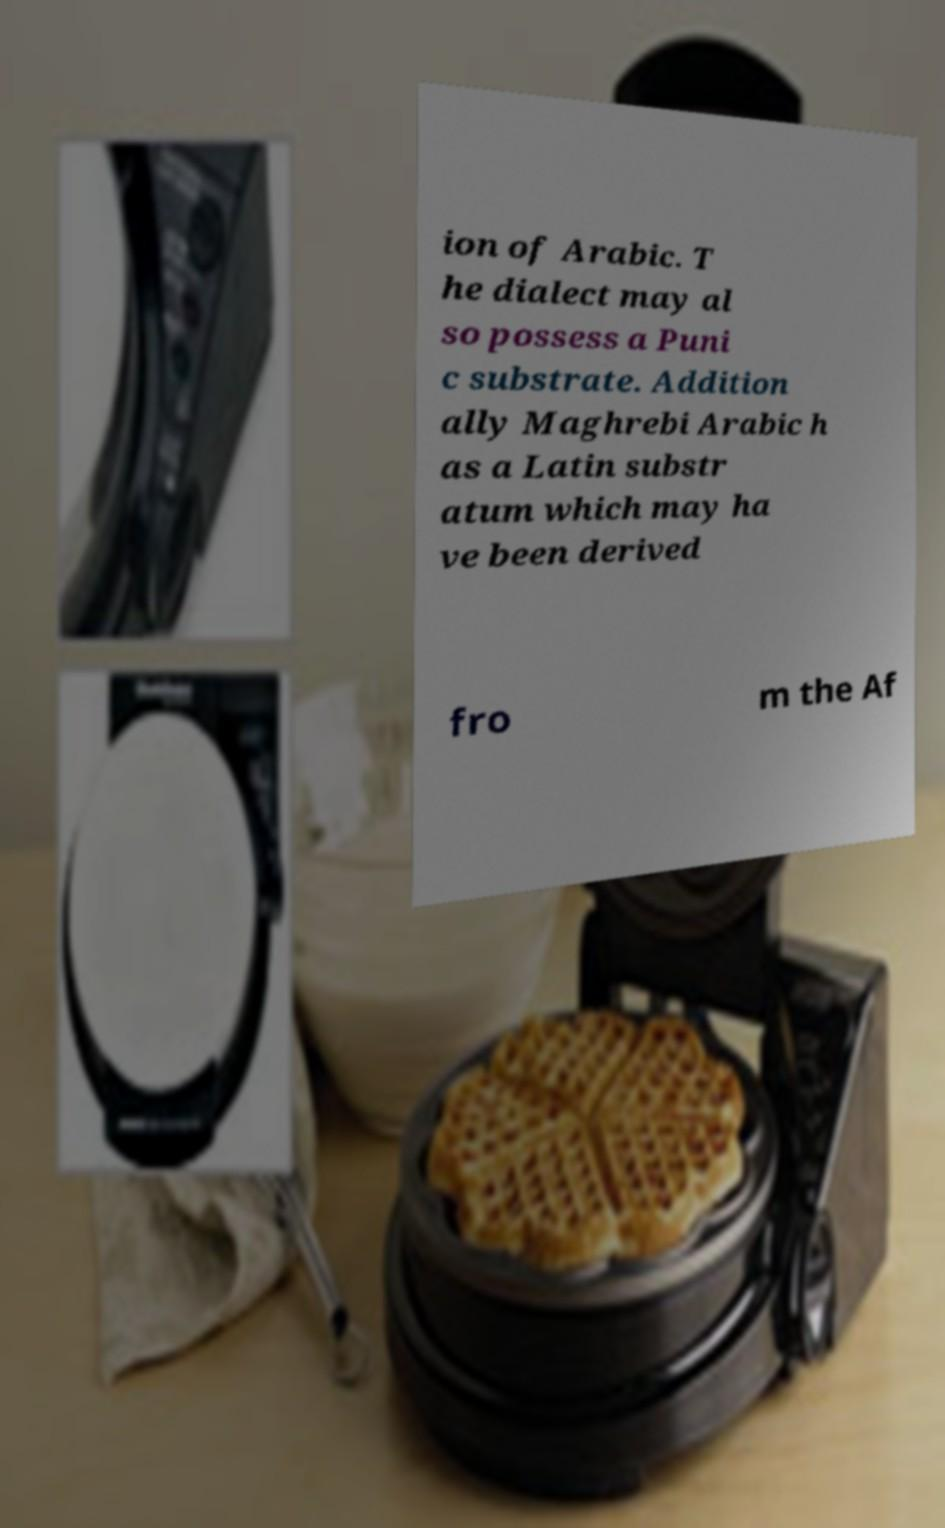Can you read and provide the text displayed in the image?This photo seems to have some interesting text. Can you extract and type it out for me? ion of Arabic. T he dialect may al so possess a Puni c substrate. Addition ally Maghrebi Arabic h as a Latin substr atum which may ha ve been derived fro m the Af 